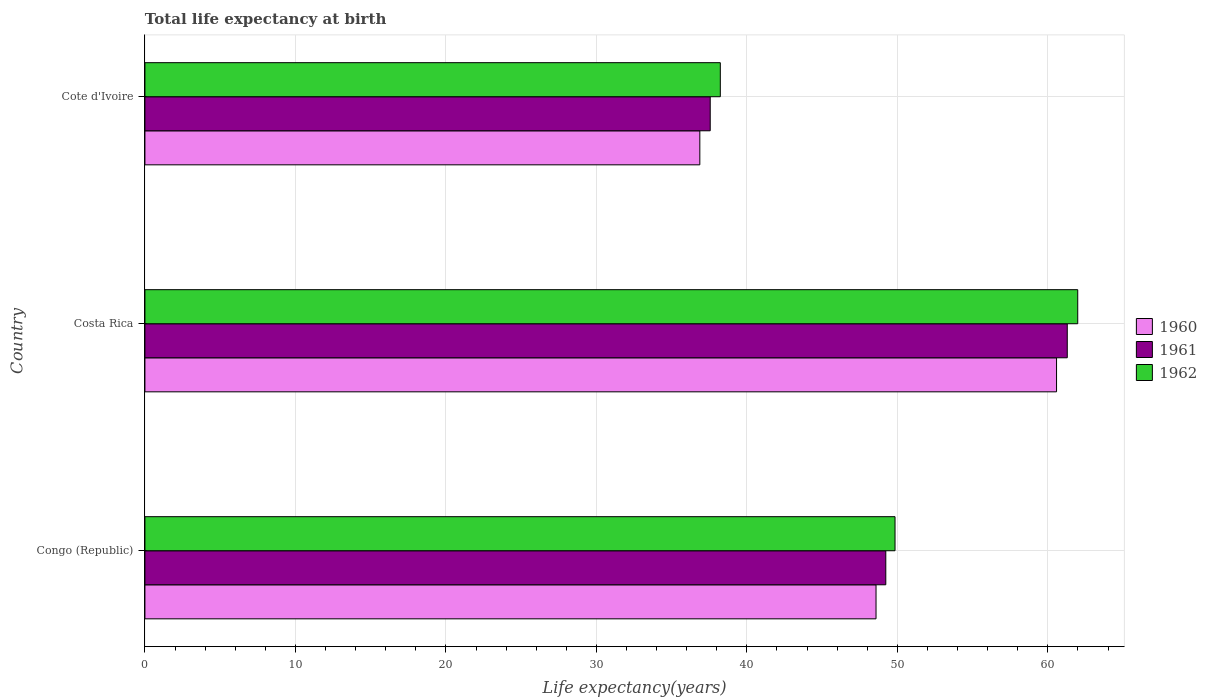How many different coloured bars are there?
Provide a succinct answer. 3. How many groups of bars are there?
Ensure brevity in your answer.  3. Are the number of bars per tick equal to the number of legend labels?
Ensure brevity in your answer.  Yes. How many bars are there on the 1st tick from the bottom?
Keep it short and to the point. 3. What is the label of the 2nd group of bars from the top?
Ensure brevity in your answer.  Costa Rica. In how many cases, is the number of bars for a given country not equal to the number of legend labels?
Make the answer very short. 0. What is the life expectancy at birth in in 1961 in Cote d'Ivoire?
Offer a very short reply. 37.56. Across all countries, what is the maximum life expectancy at birth in in 1961?
Offer a terse response. 61.29. Across all countries, what is the minimum life expectancy at birth in in 1962?
Offer a terse response. 38.23. In which country was the life expectancy at birth in in 1960 minimum?
Your answer should be compact. Cote d'Ivoire. What is the total life expectancy at birth in in 1960 in the graph?
Your answer should be compact. 146.03. What is the difference between the life expectancy at birth in in 1962 in Costa Rica and that in Cote d'Ivoire?
Make the answer very short. 23.75. What is the difference between the life expectancy at birth in in 1962 in Cote d'Ivoire and the life expectancy at birth in in 1960 in Costa Rica?
Provide a succinct answer. -22.34. What is the average life expectancy at birth in in 1961 per country?
Offer a very short reply. 49.36. What is the difference between the life expectancy at birth in in 1961 and life expectancy at birth in in 1962 in Costa Rica?
Your answer should be compact. -0.7. What is the ratio of the life expectancy at birth in in 1961 in Congo (Republic) to that in Costa Rica?
Give a very brief answer. 0.8. Is the life expectancy at birth in in 1961 in Congo (Republic) less than that in Cote d'Ivoire?
Make the answer very short. No. Is the difference between the life expectancy at birth in in 1961 in Costa Rica and Cote d'Ivoire greater than the difference between the life expectancy at birth in in 1962 in Costa Rica and Cote d'Ivoire?
Your response must be concise. No. What is the difference between the highest and the second highest life expectancy at birth in in 1961?
Provide a succinct answer. 12.06. What is the difference between the highest and the lowest life expectancy at birth in in 1960?
Provide a succinct answer. 23.7. Is the sum of the life expectancy at birth in in 1962 in Congo (Republic) and Cote d'Ivoire greater than the maximum life expectancy at birth in in 1960 across all countries?
Your answer should be very brief. Yes. What does the 2nd bar from the top in Costa Rica represents?
Your response must be concise. 1961. What does the 1st bar from the bottom in Costa Rica represents?
Offer a terse response. 1960. How many bars are there?
Your answer should be compact. 9. What is the difference between two consecutive major ticks on the X-axis?
Your answer should be very brief. 10. Are the values on the major ticks of X-axis written in scientific E-notation?
Keep it short and to the point. No. Does the graph contain any zero values?
Ensure brevity in your answer.  No. How are the legend labels stacked?
Your answer should be compact. Vertical. What is the title of the graph?
Your answer should be very brief. Total life expectancy at birth. Does "1993" appear as one of the legend labels in the graph?
Offer a terse response. No. What is the label or title of the X-axis?
Offer a very short reply. Life expectancy(years). What is the label or title of the Y-axis?
Give a very brief answer. Country. What is the Life expectancy(years) in 1960 in Congo (Republic)?
Offer a very short reply. 48.58. What is the Life expectancy(years) in 1961 in Congo (Republic)?
Your response must be concise. 49.23. What is the Life expectancy(years) of 1962 in Congo (Republic)?
Offer a very short reply. 49.84. What is the Life expectancy(years) of 1960 in Costa Rica?
Provide a succinct answer. 60.58. What is the Life expectancy(years) in 1961 in Costa Rica?
Your response must be concise. 61.29. What is the Life expectancy(years) of 1962 in Costa Rica?
Make the answer very short. 61.98. What is the Life expectancy(years) of 1960 in Cote d'Ivoire?
Ensure brevity in your answer.  36.87. What is the Life expectancy(years) in 1961 in Cote d'Ivoire?
Your answer should be very brief. 37.56. What is the Life expectancy(years) of 1962 in Cote d'Ivoire?
Ensure brevity in your answer.  38.23. Across all countries, what is the maximum Life expectancy(years) of 1960?
Your answer should be very brief. 60.58. Across all countries, what is the maximum Life expectancy(years) in 1961?
Make the answer very short. 61.29. Across all countries, what is the maximum Life expectancy(years) in 1962?
Give a very brief answer. 61.98. Across all countries, what is the minimum Life expectancy(years) of 1960?
Provide a succinct answer. 36.87. Across all countries, what is the minimum Life expectancy(years) of 1961?
Your answer should be compact. 37.56. Across all countries, what is the minimum Life expectancy(years) of 1962?
Provide a short and direct response. 38.23. What is the total Life expectancy(years) of 1960 in the graph?
Offer a very short reply. 146.03. What is the total Life expectancy(years) of 1961 in the graph?
Make the answer very short. 148.08. What is the total Life expectancy(years) in 1962 in the graph?
Ensure brevity in your answer.  150.06. What is the difference between the Life expectancy(years) in 1960 in Congo (Republic) and that in Costa Rica?
Provide a succinct answer. -11.99. What is the difference between the Life expectancy(years) of 1961 in Congo (Republic) and that in Costa Rica?
Your answer should be very brief. -12.06. What is the difference between the Life expectancy(years) of 1962 in Congo (Republic) and that in Costa Rica?
Your response must be concise. -12.14. What is the difference between the Life expectancy(years) in 1960 in Congo (Republic) and that in Cote d'Ivoire?
Make the answer very short. 11.71. What is the difference between the Life expectancy(years) of 1961 in Congo (Republic) and that in Cote d'Ivoire?
Offer a very short reply. 11.67. What is the difference between the Life expectancy(years) in 1962 in Congo (Republic) and that in Cote d'Ivoire?
Provide a short and direct response. 11.61. What is the difference between the Life expectancy(years) of 1960 in Costa Rica and that in Cote d'Ivoire?
Provide a succinct answer. 23.7. What is the difference between the Life expectancy(years) of 1961 in Costa Rica and that in Cote d'Ivoire?
Offer a very short reply. 23.73. What is the difference between the Life expectancy(years) of 1962 in Costa Rica and that in Cote d'Ivoire?
Provide a succinct answer. 23.75. What is the difference between the Life expectancy(years) of 1960 in Congo (Republic) and the Life expectancy(years) of 1961 in Costa Rica?
Provide a succinct answer. -12.71. What is the difference between the Life expectancy(years) of 1960 in Congo (Republic) and the Life expectancy(years) of 1962 in Costa Rica?
Keep it short and to the point. -13.4. What is the difference between the Life expectancy(years) of 1961 in Congo (Republic) and the Life expectancy(years) of 1962 in Costa Rica?
Your response must be concise. -12.75. What is the difference between the Life expectancy(years) of 1960 in Congo (Republic) and the Life expectancy(years) of 1961 in Cote d'Ivoire?
Provide a succinct answer. 11.02. What is the difference between the Life expectancy(years) in 1960 in Congo (Republic) and the Life expectancy(years) in 1962 in Cote d'Ivoire?
Give a very brief answer. 10.35. What is the difference between the Life expectancy(years) of 1961 in Congo (Republic) and the Life expectancy(years) of 1962 in Cote d'Ivoire?
Keep it short and to the point. 11. What is the difference between the Life expectancy(years) of 1960 in Costa Rica and the Life expectancy(years) of 1961 in Cote d'Ivoire?
Give a very brief answer. 23.01. What is the difference between the Life expectancy(years) in 1960 in Costa Rica and the Life expectancy(years) in 1962 in Cote d'Ivoire?
Your answer should be very brief. 22.34. What is the difference between the Life expectancy(years) in 1961 in Costa Rica and the Life expectancy(years) in 1962 in Cote d'Ivoire?
Ensure brevity in your answer.  23.05. What is the average Life expectancy(years) of 1960 per country?
Keep it short and to the point. 48.68. What is the average Life expectancy(years) in 1961 per country?
Your answer should be compact. 49.36. What is the average Life expectancy(years) in 1962 per country?
Keep it short and to the point. 50.02. What is the difference between the Life expectancy(years) in 1960 and Life expectancy(years) in 1961 in Congo (Republic)?
Your response must be concise. -0.65. What is the difference between the Life expectancy(years) of 1960 and Life expectancy(years) of 1962 in Congo (Republic)?
Offer a terse response. -1.26. What is the difference between the Life expectancy(years) of 1961 and Life expectancy(years) of 1962 in Congo (Republic)?
Provide a succinct answer. -0.61. What is the difference between the Life expectancy(years) in 1960 and Life expectancy(years) in 1961 in Costa Rica?
Your answer should be very brief. -0.71. What is the difference between the Life expectancy(years) of 1960 and Life expectancy(years) of 1962 in Costa Rica?
Make the answer very short. -1.41. What is the difference between the Life expectancy(years) of 1961 and Life expectancy(years) of 1962 in Costa Rica?
Provide a succinct answer. -0.7. What is the difference between the Life expectancy(years) of 1960 and Life expectancy(years) of 1961 in Cote d'Ivoire?
Offer a terse response. -0.69. What is the difference between the Life expectancy(years) in 1960 and Life expectancy(years) in 1962 in Cote d'Ivoire?
Give a very brief answer. -1.36. What is the difference between the Life expectancy(years) of 1961 and Life expectancy(years) of 1962 in Cote d'Ivoire?
Offer a terse response. -0.67. What is the ratio of the Life expectancy(years) in 1960 in Congo (Republic) to that in Costa Rica?
Your answer should be very brief. 0.8. What is the ratio of the Life expectancy(years) of 1961 in Congo (Republic) to that in Costa Rica?
Make the answer very short. 0.8. What is the ratio of the Life expectancy(years) in 1962 in Congo (Republic) to that in Costa Rica?
Make the answer very short. 0.8. What is the ratio of the Life expectancy(years) of 1960 in Congo (Republic) to that in Cote d'Ivoire?
Offer a very short reply. 1.32. What is the ratio of the Life expectancy(years) of 1961 in Congo (Republic) to that in Cote d'Ivoire?
Keep it short and to the point. 1.31. What is the ratio of the Life expectancy(years) in 1962 in Congo (Republic) to that in Cote d'Ivoire?
Keep it short and to the point. 1.3. What is the ratio of the Life expectancy(years) of 1960 in Costa Rica to that in Cote d'Ivoire?
Your answer should be compact. 1.64. What is the ratio of the Life expectancy(years) of 1961 in Costa Rica to that in Cote d'Ivoire?
Your answer should be very brief. 1.63. What is the ratio of the Life expectancy(years) in 1962 in Costa Rica to that in Cote d'Ivoire?
Offer a terse response. 1.62. What is the difference between the highest and the second highest Life expectancy(years) in 1960?
Your answer should be very brief. 11.99. What is the difference between the highest and the second highest Life expectancy(years) of 1961?
Make the answer very short. 12.06. What is the difference between the highest and the second highest Life expectancy(years) of 1962?
Your answer should be very brief. 12.14. What is the difference between the highest and the lowest Life expectancy(years) of 1960?
Your answer should be compact. 23.7. What is the difference between the highest and the lowest Life expectancy(years) of 1961?
Provide a succinct answer. 23.73. What is the difference between the highest and the lowest Life expectancy(years) of 1962?
Your response must be concise. 23.75. 